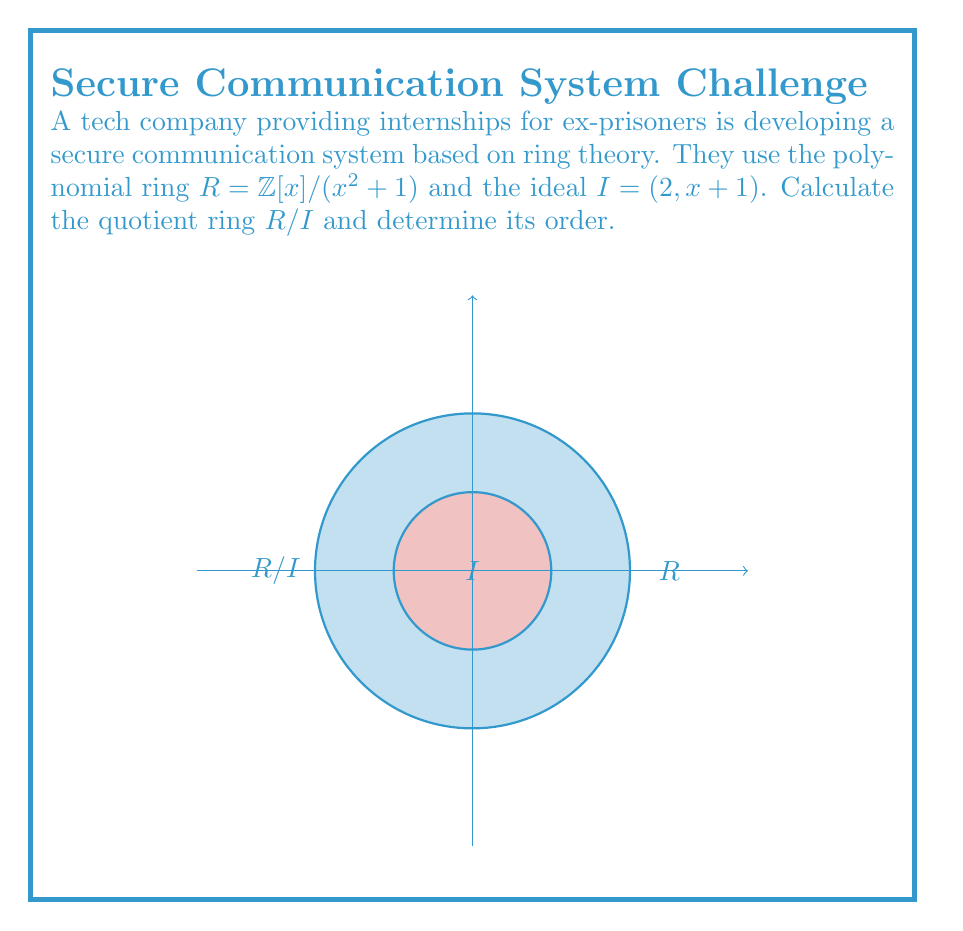Give your solution to this math problem. To calculate the quotient ring $R/I$, we follow these steps:

1) First, recall that $R = \mathbb{Z}[x]/(x^2 + 1)$, so elements of $R$ are of the form $a + bx$ where $a, b \in \mathbb{Z}$ and $x^2 \equiv -1 \pmod{R}$.

2) The ideal $I = (2, x + 1)$ consists of elements of the form $2(a + bx) + (x + 1)(c + dx)$ where $a, b, c, d \in \mathbb{Z}$.

3) In $R/I$, we have:
   $2 \equiv 0 \pmod{I}$ and $x + 1 \equiv 0 \pmod{I}$

4) From $x + 1 \equiv 0 \pmod{I}$, we get $x \equiv -1 \pmod{I}$

5) Any element $a + bx \in R$ can be written as:
   $a + bx \equiv a + b(-1) \equiv a - b \pmod{I}$

6) Since $2 \equiv 0 \pmod{I}$, we only need to consider $a - b \mod 2$

7) This means that $R/I$ has only two distinct elements: $[0]$ and $[1]$

8) Therefore, $R/I$ is isomorphic to $\mathbb{Z}/2\mathbb{Z}$, the ring of integers modulo 2

The order of a ring is the number of elements it contains. In this case, $R/I$ has 2 elements.
Answer: $R/I \cong \mathbb{Z}/2\mathbb{Z}$, order = 2 